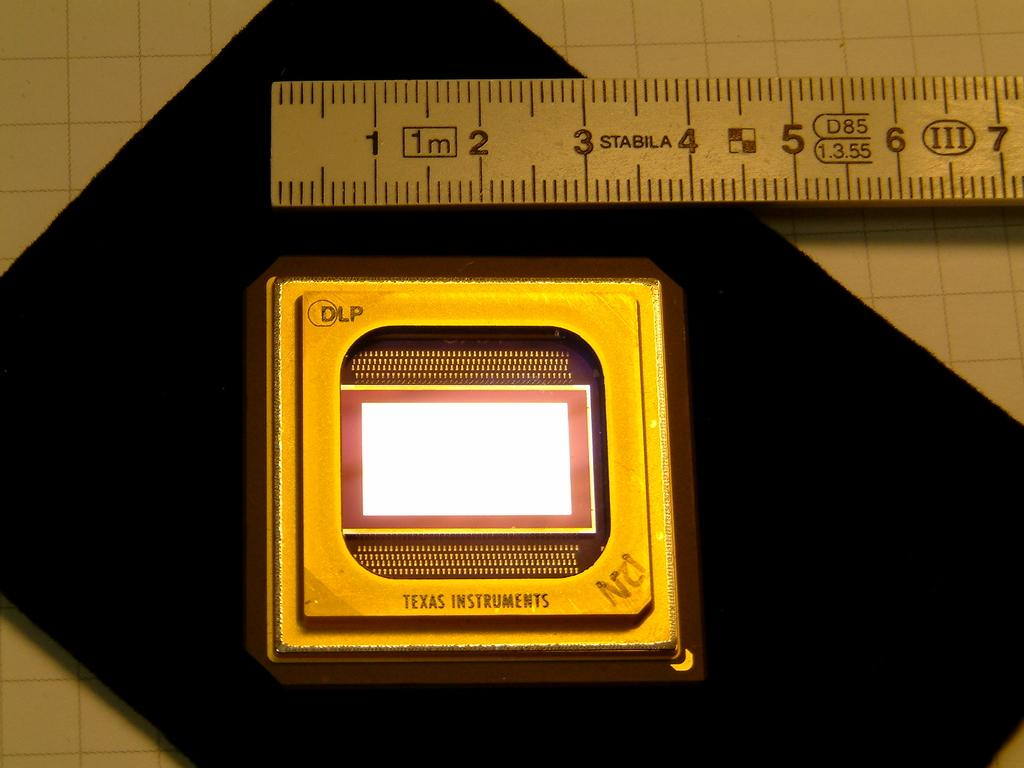<image>
Present a compact description of the photo's key features. A ruler has the brand name Stabila on the front of it. 